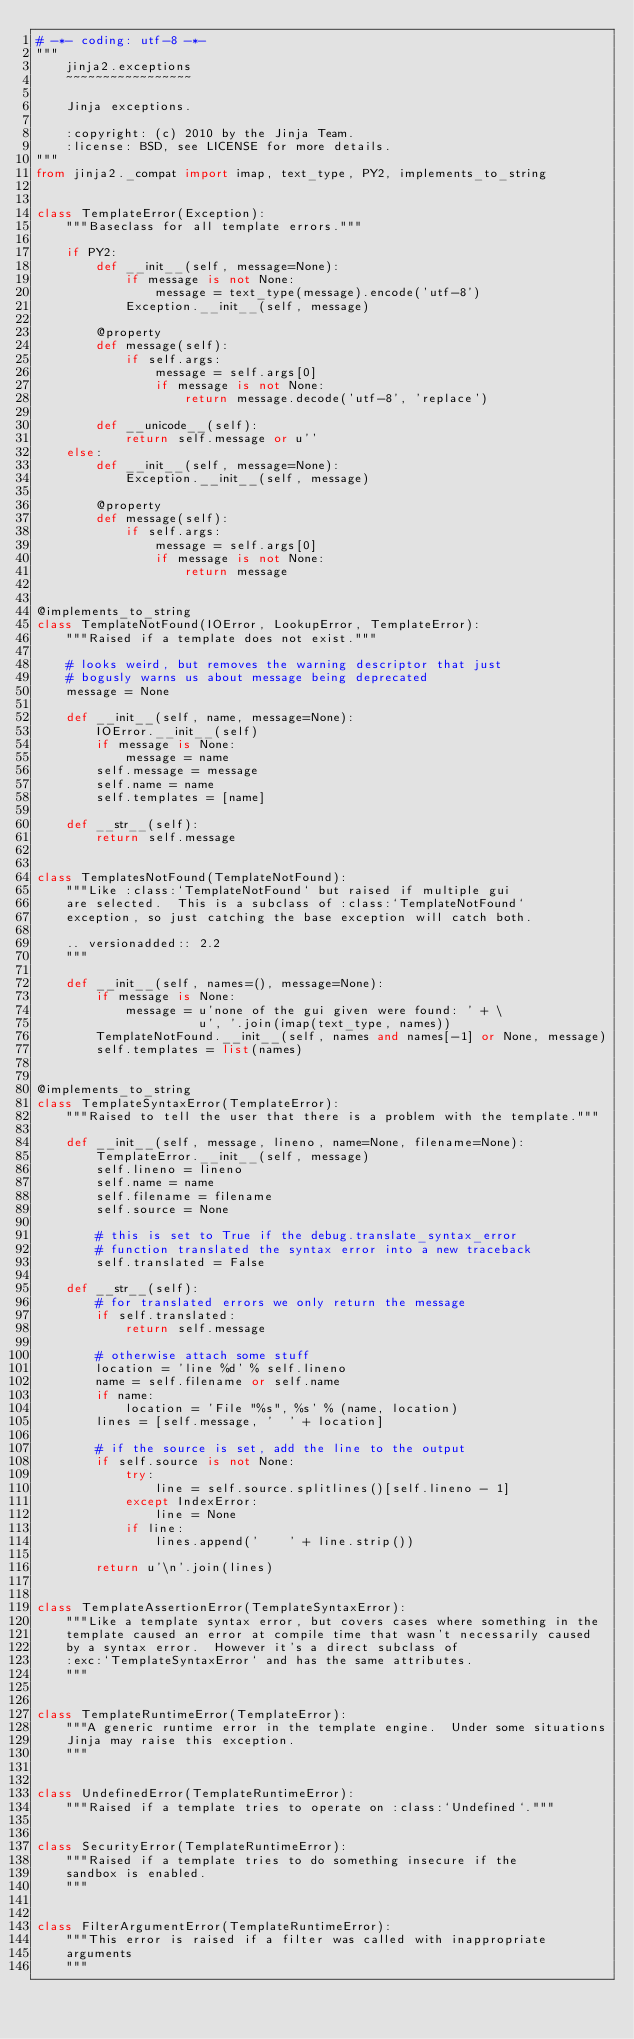<code> <loc_0><loc_0><loc_500><loc_500><_Python_># -*- coding: utf-8 -*-
"""
    jinja2.exceptions
    ~~~~~~~~~~~~~~~~~

    Jinja exceptions.

    :copyright: (c) 2010 by the Jinja Team.
    :license: BSD, see LICENSE for more details.
"""
from jinja2._compat import imap, text_type, PY2, implements_to_string


class TemplateError(Exception):
    """Baseclass for all template errors."""

    if PY2:
        def __init__(self, message=None):
            if message is not None:
                message = text_type(message).encode('utf-8')
            Exception.__init__(self, message)

        @property
        def message(self):
            if self.args:
                message = self.args[0]
                if message is not None:
                    return message.decode('utf-8', 'replace')

        def __unicode__(self):
            return self.message or u''
    else:
        def __init__(self, message=None):
            Exception.__init__(self, message)

        @property
        def message(self):
            if self.args:
                message = self.args[0]
                if message is not None:
                    return message


@implements_to_string
class TemplateNotFound(IOError, LookupError, TemplateError):
    """Raised if a template does not exist."""

    # looks weird, but removes the warning descriptor that just
    # bogusly warns us about message being deprecated
    message = None

    def __init__(self, name, message=None):
        IOError.__init__(self)
        if message is None:
            message = name
        self.message = message
        self.name = name
        self.templates = [name]

    def __str__(self):
        return self.message


class TemplatesNotFound(TemplateNotFound):
    """Like :class:`TemplateNotFound` but raised if multiple gui
    are selected.  This is a subclass of :class:`TemplateNotFound`
    exception, so just catching the base exception will catch both.

    .. versionadded:: 2.2
    """

    def __init__(self, names=(), message=None):
        if message is None:
            message = u'none of the gui given were found: ' + \
                      u', '.join(imap(text_type, names))
        TemplateNotFound.__init__(self, names and names[-1] or None, message)
        self.templates = list(names)


@implements_to_string
class TemplateSyntaxError(TemplateError):
    """Raised to tell the user that there is a problem with the template."""

    def __init__(self, message, lineno, name=None, filename=None):
        TemplateError.__init__(self, message)
        self.lineno = lineno
        self.name = name
        self.filename = filename
        self.source = None

        # this is set to True if the debug.translate_syntax_error
        # function translated the syntax error into a new traceback
        self.translated = False

    def __str__(self):
        # for translated errors we only return the message
        if self.translated:
            return self.message

        # otherwise attach some stuff
        location = 'line %d' % self.lineno
        name = self.filename or self.name
        if name:
            location = 'File "%s", %s' % (name, location)
        lines = [self.message, '  ' + location]

        # if the source is set, add the line to the output
        if self.source is not None:
            try:
                line = self.source.splitlines()[self.lineno - 1]
            except IndexError:
                line = None
            if line:
                lines.append('    ' + line.strip())

        return u'\n'.join(lines)


class TemplateAssertionError(TemplateSyntaxError):
    """Like a template syntax error, but covers cases where something in the
    template caused an error at compile time that wasn't necessarily caused
    by a syntax error.  However it's a direct subclass of
    :exc:`TemplateSyntaxError` and has the same attributes.
    """


class TemplateRuntimeError(TemplateError):
    """A generic runtime error in the template engine.  Under some situations
    Jinja may raise this exception.
    """


class UndefinedError(TemplateRuntimeError):
    """Raised if a template tries to operate on :class:`Undefined`."""


class SecurityError(TemplateRuntimeError):
    """Raised if a template tries to do something insecure if the
    sandbox is enabled.
    """


class FilterArgumentError(TemplateRuntimeError):
    """This error is raised if a filter was called with inappropriate
    arguments
    """
</code> 